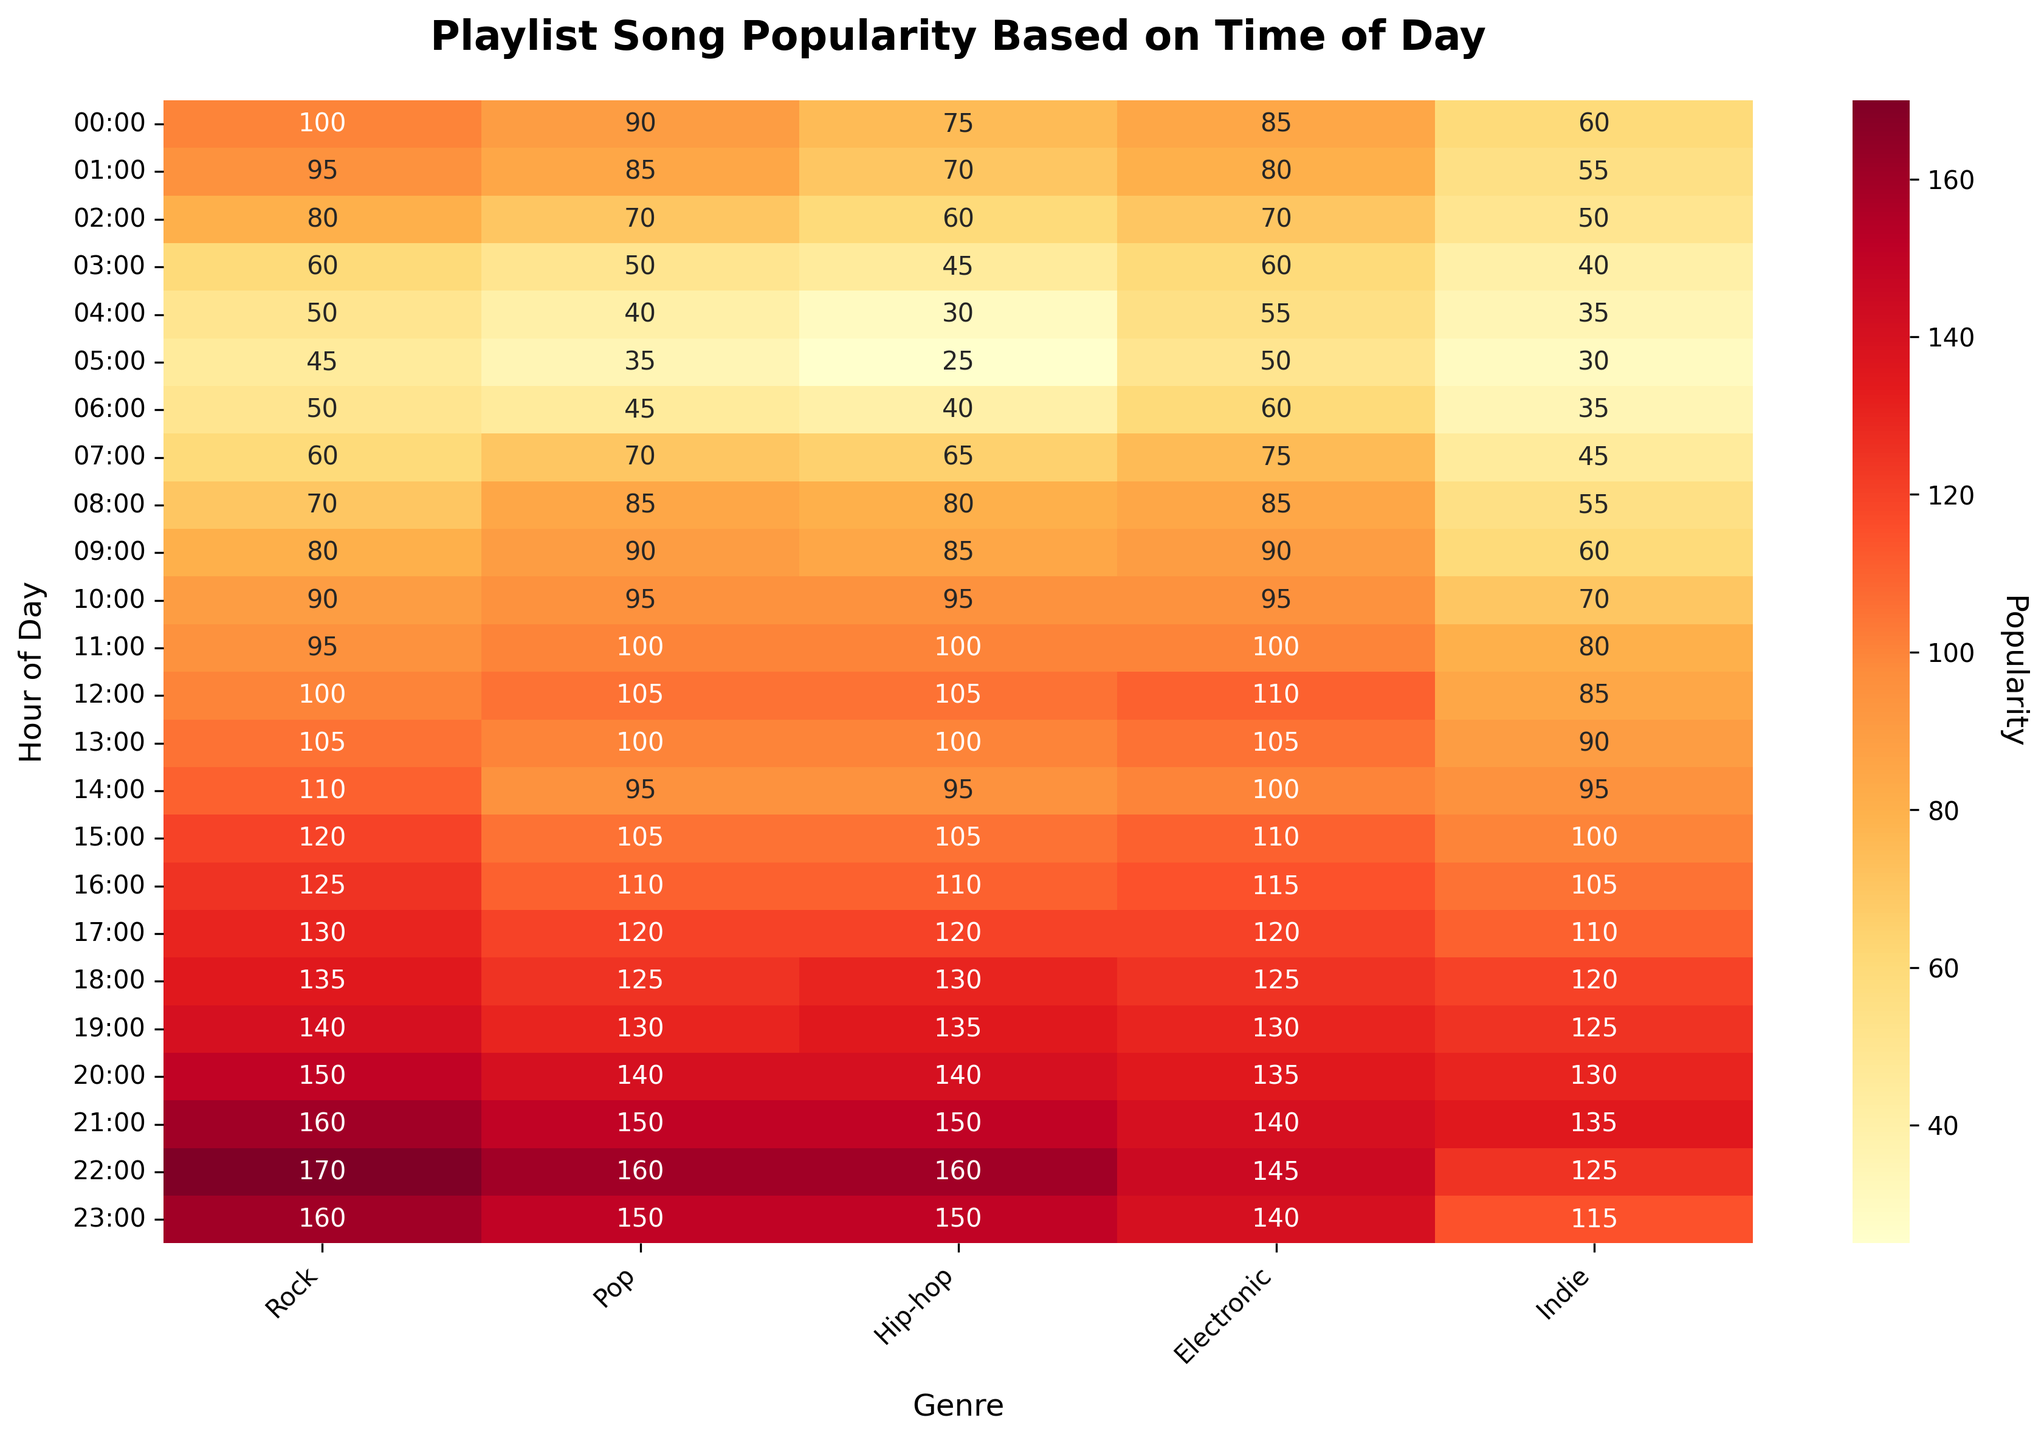What is the title of the heatmap? The title of the heatmap is usually displayed at the top center of the figure. In this case, it is 'Playlist Song Popularity Based on Time of Day'.
Answer: Playlist Song Popularity Based on Time of Day How is the popularity visually represented in the heatmap? The popularity is represented by different shades of color. Darker shades indicate higher popularity, while lighter shades indicate lower popularity. The specific color scheme used is shades of yellow to red.
Answer: Shades of yellow to red What hour has the highest popularity for the Rock genre? In the heatmap, find the row corresponding to the Rock genre and look for the highest numerical value. The highest value for Rock is 170, which occurs at 22:00.
Answer: 22:00 What is the popularity of Hip-hop at 10:00? Find the intersection of the row corresponding to 10:00 and the column for Hip-hop. The number displayed at this intersection is the popularity. For Hip-hop at 10:00, the value is 95.
Answer: 95 Which genre has the lowest popularity at 04:00? Find the row corresponding to 04:00 and compare all values in that row. The lowest value is 30, which belongs to the Hip-hop genre.
Answer: Hip-hop What is the average popularity for Pop between 07:00 and 12:00? Find the values of Pop between 07:00 and 12:00, which are 70, 85, 90, 95, 100, and 105. Sum these values (70 + 85 + 90 + 95 + 100 + 105 = 545) and divide by the number of hours (6). The average is 545 / 6 ≈ 90.8.
Answer: 90.8 Compare the popularity of Electronic at 14:00 and 20:00. Which one is higher? Find the values for Electronic at both times. Electronic at 14:00 has a popularity of 100, while at 20:00, it is 135. Since 135 is greater than 100, the popularity at 20:00 is higher.
Answer: 20:00 At what hour does the Indie genre start to see a significant increase in its popularity? Observe the heatmap for the Indie genre column and look for the hour where there is a considerable increase in value. The popularity starts to significantly increase at 17:00.
Answer: 17:00 Which two genres have the closest popularity values at 21:00? Find the values for all genres at 21:00: Rock (160), Pop (150), Hip-hop (150), Electronic (140), Indie (135). The two closest values are for Pop and Hip-hop, both at 150.
Answer: Pop and Hip-hop What is the total popularity for all genres at 18:00? Add the values for all genres at 18:00: Rock (135), Pop (125), Hip-hop (130), Electronic (125), Indie (120). The total is 135 + 125 + 130 + 125 + 120 = 635.
Answer: 635 